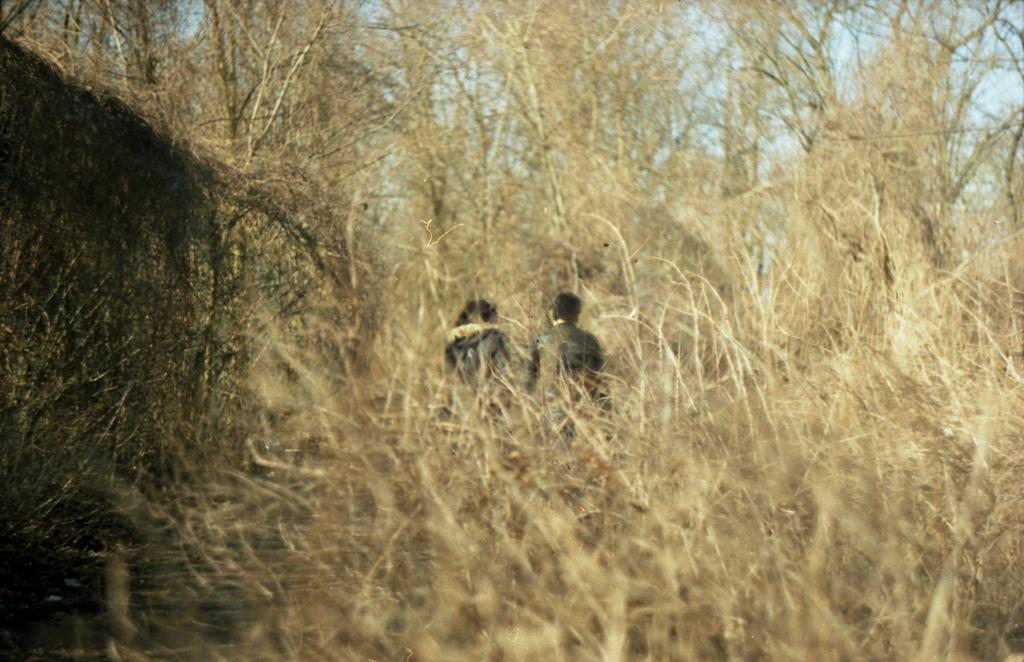What type of vegetation is present in the image? There are many dry plants and trees in the image. How many people are in the image? There are two persons in the image. What direction are the two persons facing? The two persons are facing towards the back side. What items are on the list that the two persons are holding in the image? There is no list present in the image, and the two persons are not holding anything. How many friends are visible in the image? There is no mention of friends in the image; only two persons are present. 